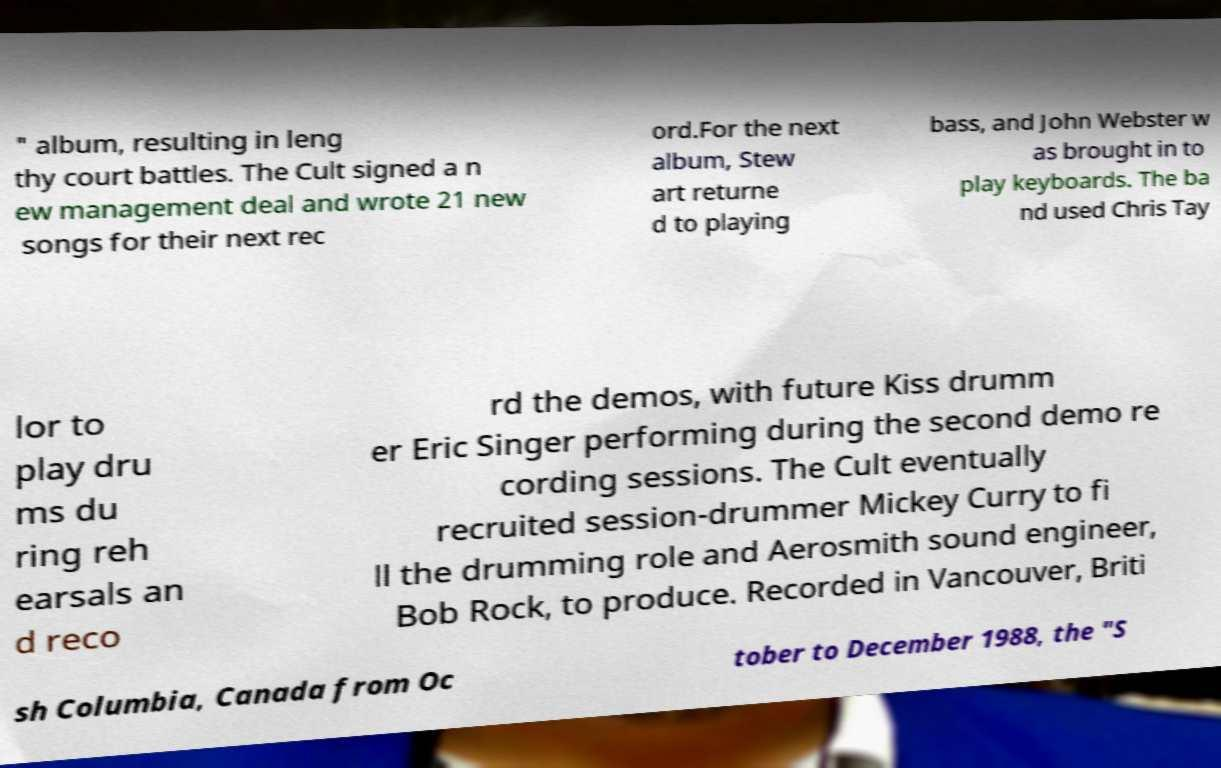Can you read and provide the text displayed in the image?This photo seems to have some interesting text. Can you extract and type it out for me? " album, resulting in leng thy court battles. The Cult signed a n ew management deal and wrote 21 new songs for their next rec ord.For the next album, Stew art returne d to playing bass, and John Webster w as brought in to play keyboards. The ba nd used Chris Tay lor to play dru ms du ring reh earsals an d reco rd the demos, with future Kiss drumm er Eric Singer performing during the second demo re cording sessions. The Cult eventually recruited session-drummer Mickey Curry to fi ll the drumming role and Aerosmith sound engineer, Bob Rock, to produce. Recorded in Vancouver, Briti sh Columbia, Canada from Oc tober to December 1988, the "S 